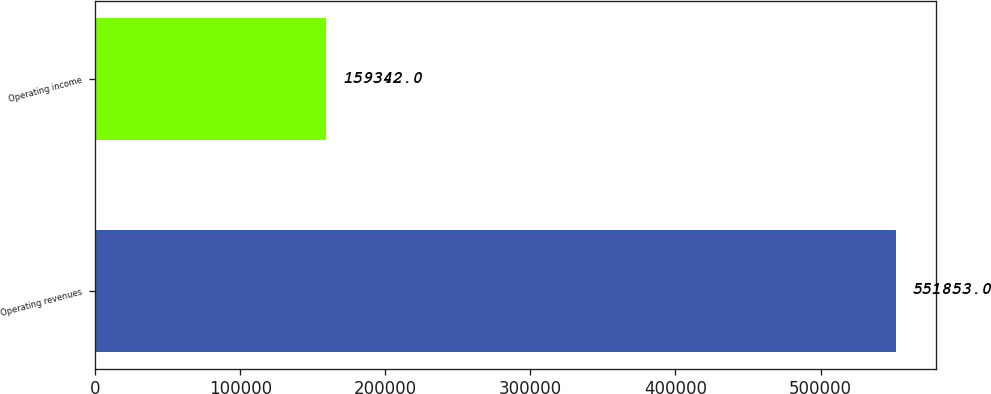Convert chart to OTSL. <chart><loc_0><loc_0><loc_500><loc_500><bar_chart><fcel>Operating revenues<fcel>Operating income<nl><fcel>551853<fcel>159342<nl></chart> 